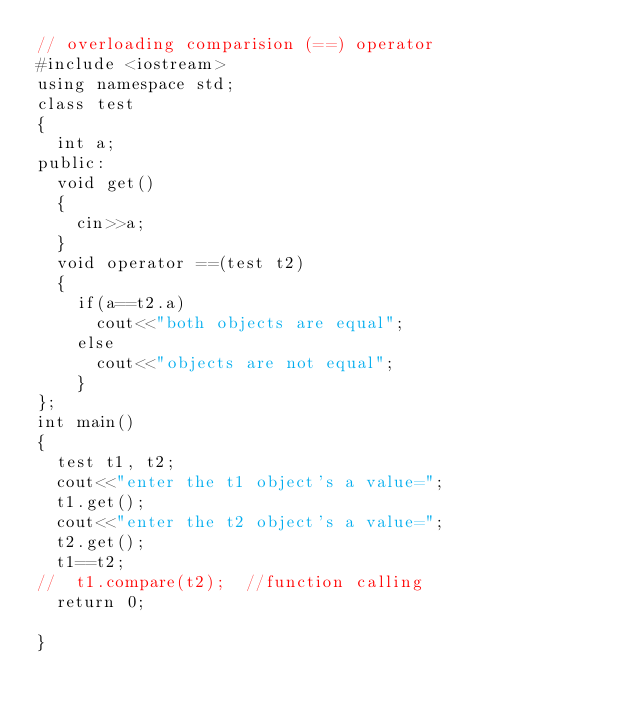<code> <loc_0><loc_0><loc_500><loc_500><_C++_>// overloading comparision (==) operator
#include <iostream>
using namespace std;
class test
{
	int a;
public:
	void get()
	{
		cin>>a;
	}
	void operator ==(test t2)
	{
		if(a==t2.a)
			cout<<"both objects are equal";
		else
			cout<<"objects are not equal";
		}
};
int main()
{
	test t1, t2;
	cout<<"enter the t1 object's a value=";
	t1.get();
	cout<<"enter the t2 object's a value=";
	t2.get();
	t1==t2;
//	t1.compare(t2);  //function calling
	return 0;

}</code> 